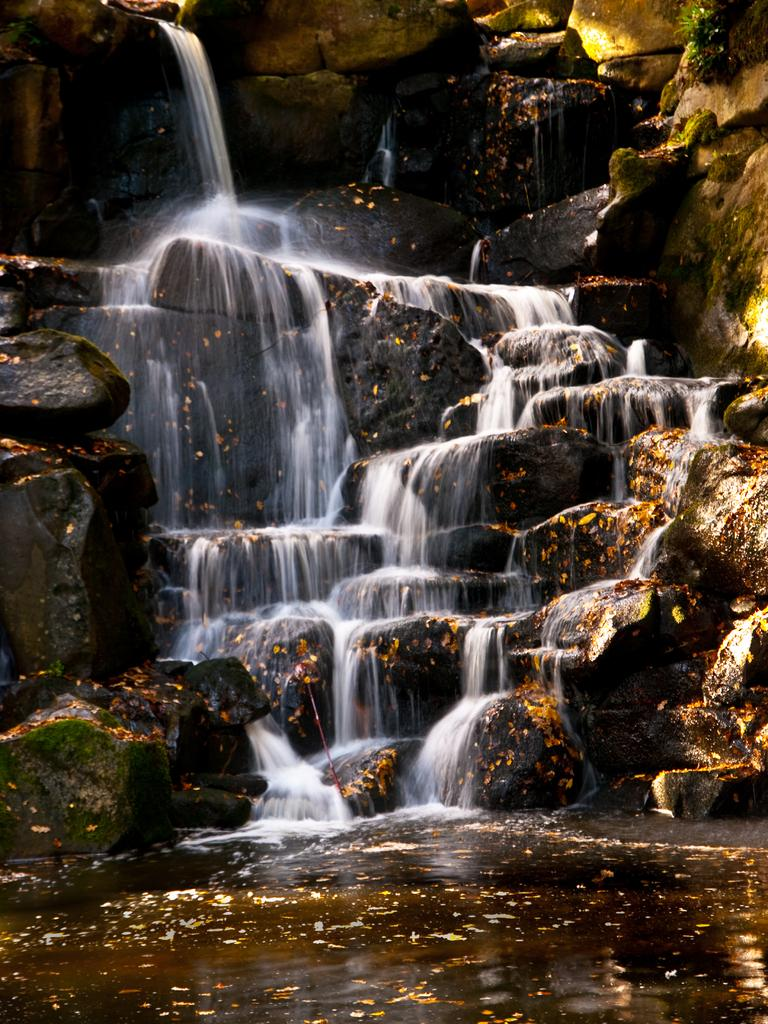What is in the foreground of the image? There is water in the foreground of the image. What natural feature can be seen in the image? There is a waterfall in the image. What type of geological formation is visible in the image? There are rocks visible in the image. How many cans are visible in the image? There are no cans present in the image. What type of cat can be seen climbing the waterfall in the image? There is no cat present in the image, and therefore no such activity can be observed. 